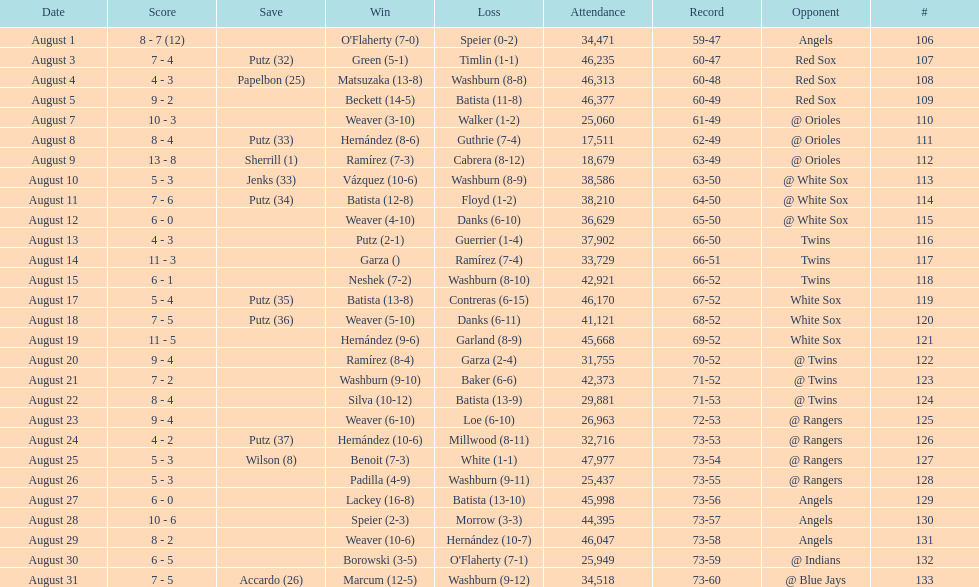What was the total number of games played in august 2007? 28. 